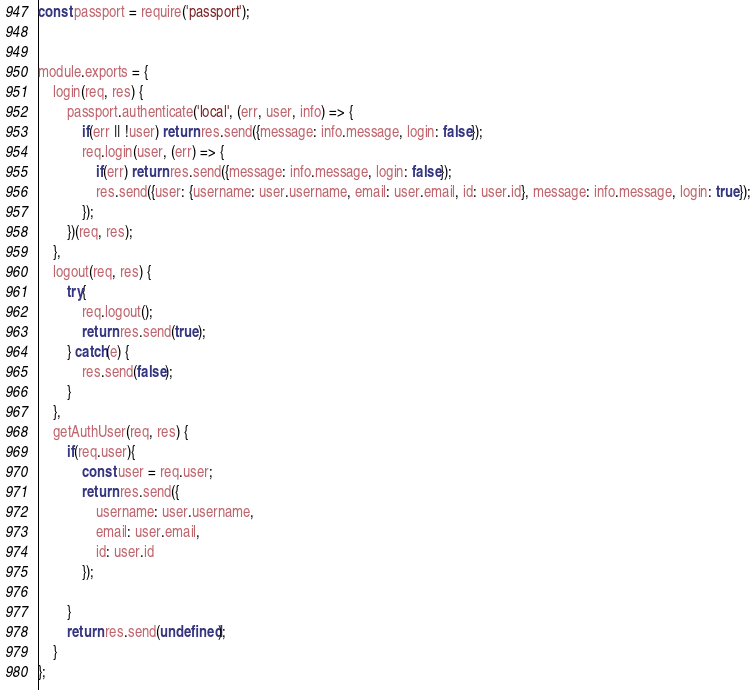Convert code to text. <code><loc_0><loc_0><loc_500><loc_500><_JavaScript_>const passport = require('passport');


module.exports = {
	login(req, res) {
		passport.authenticate('local', (err, user, info) => {
			if(err || !user) return res.send({message: info.message, login: false});
			req.login(user, (err) => {
				if(err) return res.send({message: info.message, login: false});
				res.send({user: {username: user.username, email: user.email, id: user.id}, message: info.message, login: true});
			});
		})(req, res);
	},
	logout(req, res) {
		try{
			req.logout();
			return res.send(true);
		} catch(e) {
			res.send(false);
		}
	},
	getAuthUser(req, res) {
		if(req.user){
			const user = req.user;
			return res.send({
				username: user.username,
				email: user.email,
				id: user.id
			});

		}
		return res.send(undefined);
	}
};
</code> 